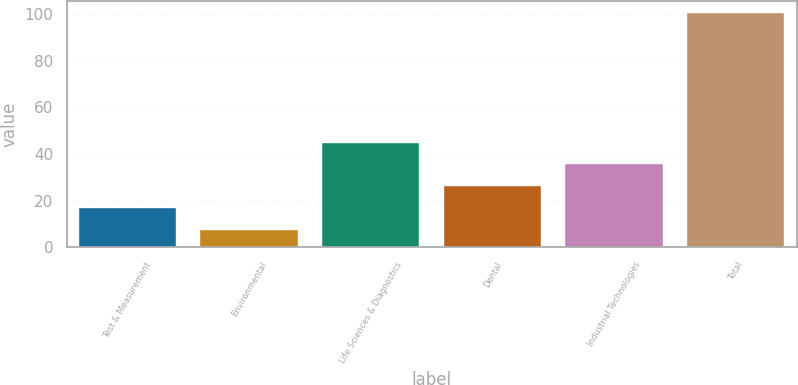Convert chart to OTSL. <chart><loc_0><loc_0><loc_500><loc_500><bar_chart><fcel>Test & Measurement<fcel>Environmental<fcel>Life Sciences & Diagnostics<fcel>Dental<fcel>Industrial Technologies<fcel>Total<nl><fcel>16.73<fcel>7.4<fcel>44.93<fcel>26.06<fcel>35.6<fcel>100.7<nl></chart> 